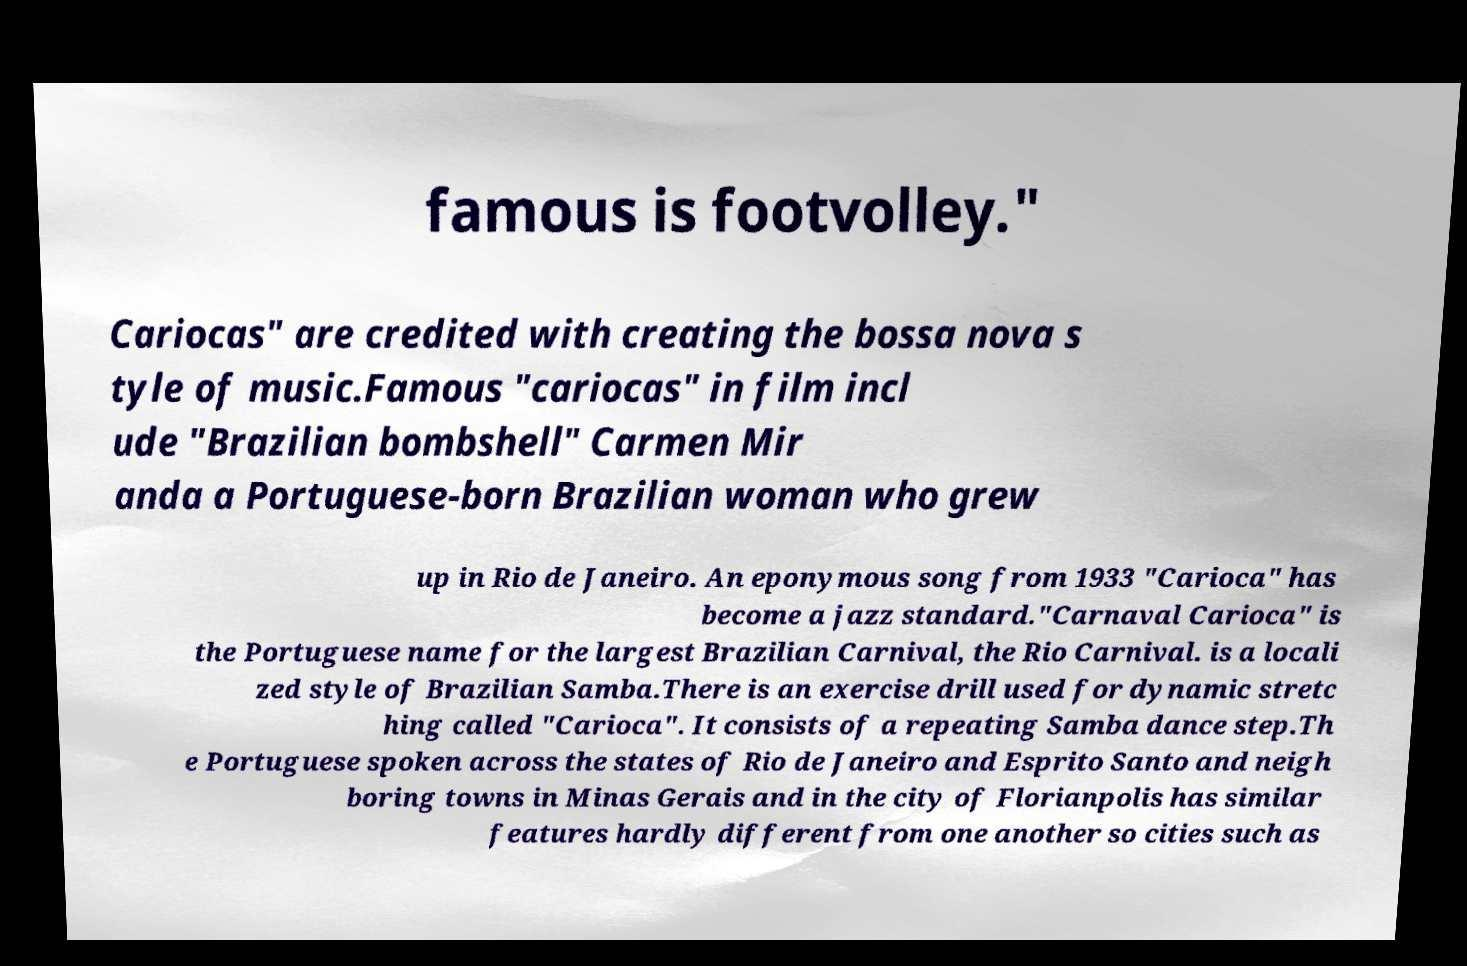Please read and relay the text visible in this image. What does it say? famous is footvolley." Cariocas" are credited with creating the bossa nova s tyle of music.Famous "cariocas" in film incl ude "Brazilian bombshell" Carmen Mir anda a Portuguese-born Brazilian woman who grew up in Rio de Janeiro. An eponymous song from 1933 "Carioca" has become a jazz standard."Carnaval Carioca" is the Portuguese name for the largest Brazilian Carnival, the Rio Carnival. is a locali zed style of Brazilian Samba.There is an exercise drill used for dynamic stretc hing called "Carioca". It consists of a repeating Samba dance step.Th e Portuguese spoken across the states of Rio de Janeiro and Esprito Santo and neigh boring towns in Minas Gerais and in the city of Florianpolis has similar features hardly different from one another so cities such as 